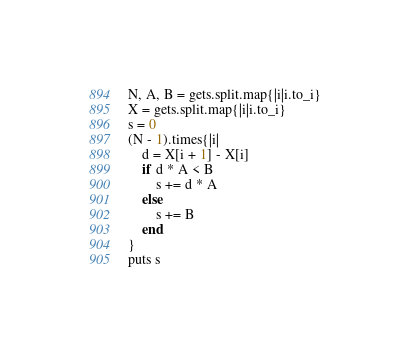Convert code to text. <code><loc_0><loc_0><loc_500><loc_500><_Ruby_>N, A, B = gets.split.map{|i|i.to_i}
X = gets.split.map{|i|i.to_i}
s = 0
(N - 1).times{|i|
    d = X[i + 1] - X[i]
    if d * A < B
        s += d * A
    else
        s += B
    end
}
puts s
</code> 